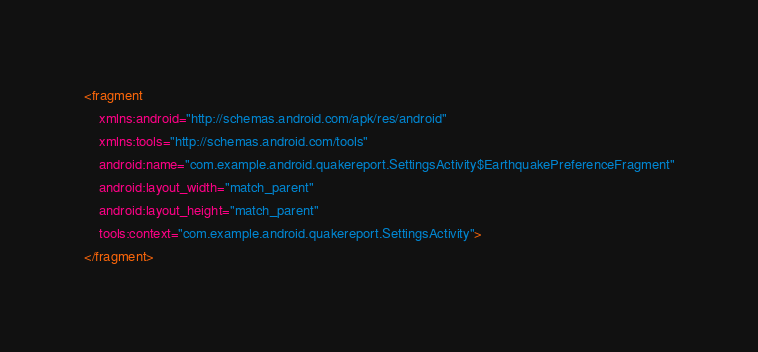<code> <loc_0><loc_0><loc_500><loc_500><_XML_><fragment
    xmlns:android="http://schemas.android.com/apk/res/android"
    xmlns:tools="http://schemas.android.com/tools"
    android:name="com.example.android.quakereport.SettingsActivity$EarthquakePreferenceFragment"
    android:layout_width="match_parent"
    android:layout_height="match_parent"
    tools:context="com.example.android.quakereport.SettingsActivity">
</fragment></code> 